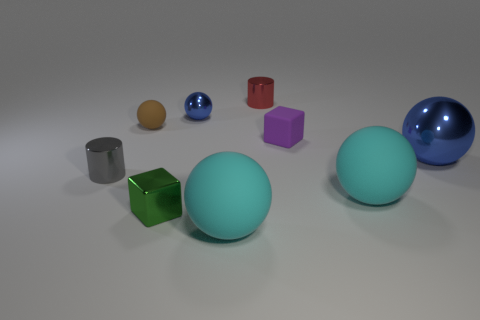What could be the significance of the arrangement of these objects? The arrangement of these objects may be designed to demonstrate the contrast in colors, sizes, and shapes. For instance, the placement might be aiming to showcase how light interacts differently with surfaces, creating a visual experience of reflection and absorption. It could also be an abstract representation to illustrate concepts of geometry and spatial perception, or simply an aesthetically pleasing composition with no inherent significance beyond the joy of observing diverse forms. 